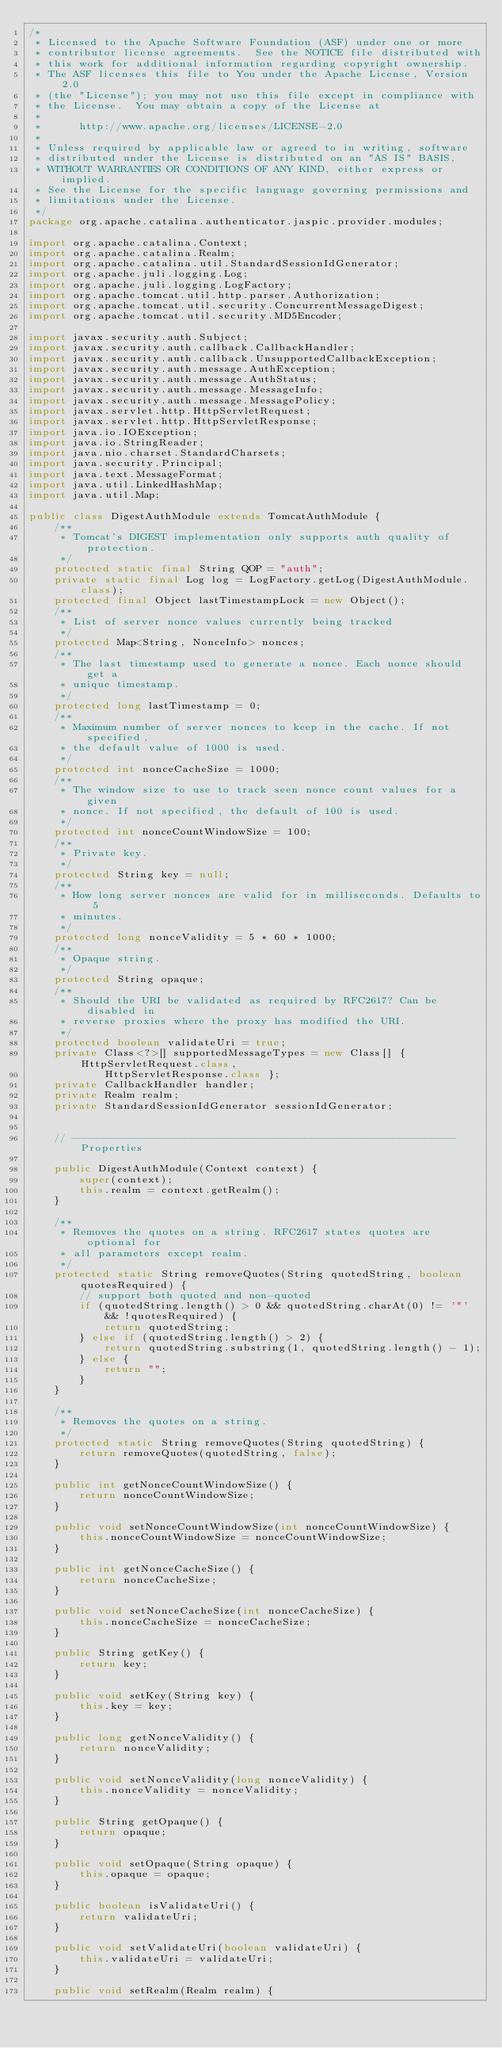Convert code to text. <code><loc_0><loc_0><loc_500><loc_500><_Java_>/*
 * Licensed to the Apache Software Foundation (ASF) under one or more
 * contributor license agreements.  See the NOTICE file distributed with
 * this work for additional information regarding copyright ownership.
 * The ASF licenses this file to You under the Apache License, Version 2.0
 * (the "License"); you may not use this file except in compliance with
 * the License.  You may obtain a copy of the License at
 *
 *      http://www.apache.org/licenses/LICENSE-2.0
 *
 * Unless required by applicable law or agreed to in writing, software
 * distributed under the License is distributed on an "AS IS" BASIS,
 * WITHOUT WARRANTIES OR CONDITIONS OF ANY KIND, either express or implied.
 * See the License for the specific language governing permissions and
 * limitations under the License.
 */
package org.apache.catalina.authenticator.jaspic.provider.modules;

import org.apache.catalina.Context;
import org.apache.catalina.Realm;
import org.apache.catalina.util.StandardSessionIdGenerator;
import org.apache.juli.logging.Log;
import org.apache.juli.logging.LogFactory;
import org.apache.tomcat.util.http.parser.Authorization;
import org.apache.tomcat.util.security.ConcurrentMessageDigest;
import org.apache.tomcat.util.security.MD5Encoder;

import javax.security.auth.Subject;
import javax.security.auth.callback.CallbackHandler;
import javax.security.auth.callback.UnsupportedCallbackException;
import javax.security.auth.message.AuthException;
import javax.security.auth.message.AuthStatus;
import javax.security.auth.message.MessageInfo;
import javax.security.auth.message.MessagePolicy;
import javax.servlet.http.HttpServletRequest;
import javax.servlet.http.HttpServletResponse;
import java.io.IOException;
import java.io.StringReader;
import java.nio.charset.StandardCharsets;
import java.security.Principal;
import java.text.MessageFormat;
import java.util.LinkedHashMap;
import java.util.Map;

public class DigestAuthModule extends TomcatAuthModule {
    /**
     * Tomcat's DIGEST implementation only supports auth quality of protection.
     */
    protected static final String QOP = "auth";
    private static final Log log = LogFactory.getLog(DigestAuthModule.class);
    protected final Object lastTimestampLock = new Object();
    /**
     * List of server nonce values currently being tracked
     */
    protected Map<String, NonceInfo> nonces;
    /**
     * The last timestamp used to generate a nonce. Each nonce should get a
     * unique timestamp.
     */
    protected long lastTimestamp = 0;
    /**
     * Maximum number of server nonces to keep in the cache. If not specified,
     * the default value of 1000 is used.
     */
    protected int nonceCacheSize = 1000;
    /**
     * The window size to use to track seen nonce count values for a given
     * nonce. If not specified, the default of 100 is used.
     */
    protected int nonceCountWindowSize = 100;
    /**
     * Private key.
     */
    protected String key = null;
    /**
     * How long server nonces are valid for in milliseconds. Defaults to 5
     * minutes.
     */
    protected long nonceValidity = 5 * 60 * 1000;
    /**
     * Opaque string.
     */
    protected String opaque;
    /**
     * Should the URI be validated as required by RFC2617? Can be disabled in
     * reverse proxies where the proxy has modified the URI.
     */
    protected boolean validateUri = true;
    private Class<?>[] supportedMessageTypes = new Class[] { HttpServletRequest.class,
            HttpServletResponse.class };
    private CallbackHandler handler;
    private Realm realm;
    private StandardSessionIdGenerator sessionIdGenerator;


    // ------------------------------------------------------------- Properties

    public DigestAuthModule(Context context) {
        super(context);
        this.realm = context.getRealm();
    }

    /**
     * Removes the quotes on a string. RFC2617 states quotes are optional for
     * all parameters except realm.
     */
    protected static String removeQuotes(String quotedString, boolean quotesRequired) {
        // support both quoted and non-quoted
        if (quotedString.length() > 0 && quotedString.charAt(0) != '"' && !quotesRequired) {
            return quotedString;
        } else if (quotedString.length() > 2) {
            return quotedString.substring(1, quotedString.length() - 1);
        } else {
            return "";
        }
    }

    /**
     * Removes the quotes on a string.
     */
    protected static String removeQuotes(String quotedString) {
        return removeQuotes(quotedString, false);
    }

    public int getNonceCountWindowSize() {
        return nonceCountWindowSize;
    }

    public void setNonceCountWindowSize(int nonceCountWindowSize) {
        this.nonceCountWindowSize = nonceCountWindowSize;
    }

    public int getNonceCacheSize() {
        return nonceCacheSize;
    }

    public void setNonceCacheSize(int nonceCacheSize) {
        this.nonceCacheSize = nonceCacheSize;
    }

    public String getKey() {
        return key;
    }

    public void setKey(String key) {
        this.key = key;
    }

    public long getNonceValidity() {
        return nonceValidity;
    }

    public void setNonceValidity(long nonceValidity) {
        this.nonceValidity = nonceValidity;
    }

    public String getOpaque() {
        return opaque;
    }

    public void setOpaque(String opaque) {
        this.opaque = opaque;
    }

    public boolean isValidateUri() {
        return validateUri;
    }

    public void setValidateUri(boolean validateUri) {
        this.validateUri = validateUri;
    }

    public void setRealm(Realm realm) {</code> 